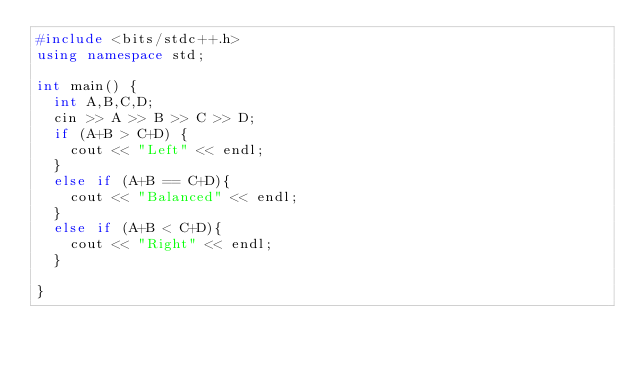Convert code to text. <code><loc_0><loc_0><loc_500><loc_500><_C++_>#include <bits/stdc++.h>
using namespace std;

int main() {
  int A,B,C,D;
  cin >> A >> B >> C >> D;
  if (A+B > C+D) {
    cout << "Left" << endl;
  }
  else if (A+B == C+D){
    cout << "Balanced" << endl;
  }
  else if (A+B < C+D){
    cout << "Right" << endl;
  }
  
}</code> 